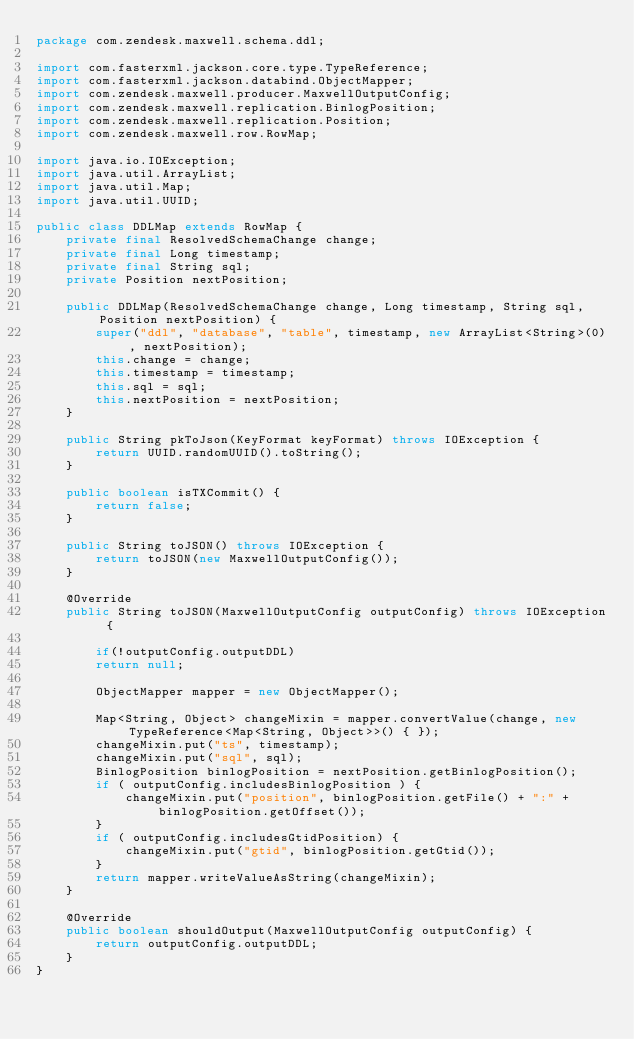Convert code to text. <code><loc_0><loc_0><loc_500><loc_500><_Java_>package com.zendesk.maxwell.schema.ddl;

import com.fasterxml.jackson.core.type.TypeReference;
import com.fasterxml.jackson.databind.ObjectMapper;
import com.zendesk.maxwell.producer.MaxwellOutputConfig;
import com.zendesk.maxwell.replication.BinlogPosition;
import com.zendesk.maxwell.replication.Position;
import com.zendesk.maxwell.row.RowMap;

import java.io.IOException;
import java.util.ArrayList;
import java.util.Map;
import java.util.UUID;

public class DDLMap extends RowMap {
	private final ResolvedSchemaChange change;
	private final Long timestamp;
	private final String sql;
	private Position nextPosition;

	public DDLMap(ResolvedSchemaChange change, Long timestamp, String sql, Position nextPosition) {
		super("ddl", "database", "table", timestamp, new ArrayList<String>(0), nextPosition);
		this.change = change;
		this.timestamp = timestamp;
		this.sql = sql;
		this.nextPosition = nextPosition;
	}

	public String pkToJson(KeyFormat keyFormat) throws IOException {
		return UUID.randomUUID().toString();
	}

	public boolean isTXCommit() {
		return false;
	}

	public String toJSON() throws IOException {
		return toJSON(new MaxwellOutputConfig());
	}

	@Override
	public String toJSON(MaxwellOutputConfig outputConfig) throws IOException {

		if(!outputConfig.outputDDL)
		return null;

		ObjectMapper mapper = new ObjectMapper();

		Map<String, Object> changeMixin = mapper.convertValue(change, new TypeReference<Map<String, Object>>() { });
		changeMixin.put("ts", timestamp);
		changeMixin.put("sql", sql);
		BinlogPosition binlogPosition = nextPosition.getBinlogPosition();
		if ( outputConfig.includesBinlogPosition ) {
			changeMixin.put("position", binlogPosition.getFile() + ":" + binlogPosition.getOffset());
		}
		if ( outputConfig.includesGtidPosition) {
			changeMixin.put("gtid", binlogPosition.getGtid());
		}
		return mapper.writeValueAsString(changeMixin);
	}

	@Override
	public boolean shouldOutput(MaxwellOutputConfig outputConfig) {
		return outputConfig.outputDDL;
	}
}
</code> 